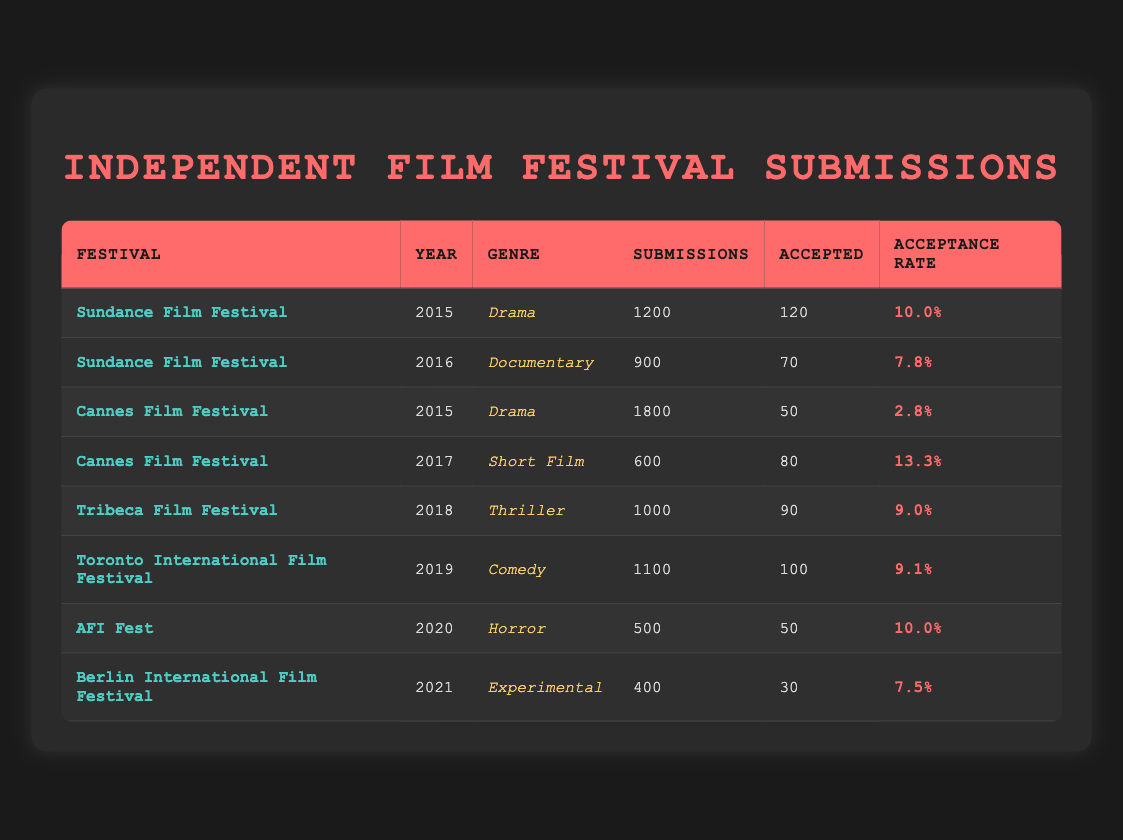What was the highest acceptance rate by genre among the data? Looking at the table, the highest acceptance rate is 13.3%, which occurs for the Short Film genre at the Cannes Film Festival in 2017.
Answer: 13.3% In which year did the Sundance Film Festival have the most submissions? The table shows that the Sundance Film Festival had 1200 submissions in 2015, which is the highest number of submissions listed.
Answer: 2015 What is the average acceptance rate for all genres across the festivals? To find the average acceptance rate, add all acceptance rates (10.0 + 7.8 + 2.8 + 13.3 + 9.0 + 9.1 + 10.0 + 7.5 = 69.5) and divide by the total number of genres (8). This gives an average acceptance rate of 69.5/8 = 8.6875%.
Answer: 8.69% Did any festival have a higher acceptance rate for Horror compared to the overall acceptance rate for all submitted films? The only entry for Horror is at AFI Fest with an acceptance rate of 10.0%. The average acceptance rate calculated previously is approximately 8.69%. Since 10.0% is greater than 8.69%, the answer is yes.
Answer: Yes Which festival had the least number of accepted submissions and what genre was it? By analyzing the data, the least number of accepted submissions is 30 at the Berlin International Film Festival for the genre Experimental in 2021.
Answer: Berlin International Film Festival, Experimental What is the difference in submission numbers between the highest and lowest submissions across all festivals? The highest submissions recorded are 1800 at the Cannes Film Festival (2015), and the lowest are 400 at the Berlin International Film Festival (2021). The difference is 1800 - 400 = 1400.
Answer: 1400 How many accepted submissions were there for the Thriller genre? The table indicates that there were 90 accepted submissions for the Thriller genre at the Tribeca Film Festival in 2018.
Answer: 90 Was the number of submissions for Comedy higher than that for Documentary? The number of submissions for Comedy at the Toronto International Film Festival is 1100, while the number for Documentary at the Sundance Film Festival is 900. Since 1100 is greater than 900, the answer is yes.
Answer: Yes 